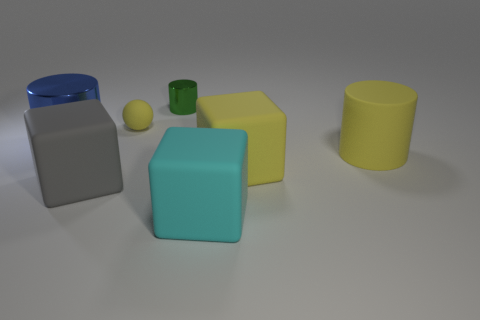There is a matte block left of the shiny object right of the tiny ball; are there any tiny green things that are to the right of it?
Keep it short and to the point. Yes. What is the material of the big gray thing that is the same shape as the big cyan thing?
Your answer should be compact. Rubber. Are there any other things that have the same material as the tiny yellow object?
Keep it short and to the point. Yes. Is the material of the big cyan thing the same as the cube that is behind the large gray rubber object?
Provide a succinct answer. Yes. What shape is the metal object behind the ball that is on the left side of the big yellow cube?
Offer a terse response. Cylinder. How many large objects are either rubber cylinders or green metal cylinders?
Ensure brevity in your answer.  1. What number of other yellow rubber objects have the same shape as the tiny yellow rubber thing?
Offer a very short reply. 0. There is a big gray object; is its shape the same as the yellow object that is left of the cyan matte object?
Your answer should be very brief. No. There is a big gray thing; how many small green metal objects are in front of it?
Provide a short and direct response. 0. Is there a green metal cube that has the same size as the cyan cube?
Your answer should be very brief. No. 